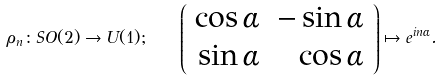<formula> <loc_0><loc_0><loc_500><loc_500>\rho _ { n } \colon S O ( 2 ) \to U ( 1 ) ; \quad \left ( \begin{array} { r r } \cos \alpha & - \sin \alpha \\ \sin \alpha & \cos \alpha \end{array} \right ) \mapsto e ^ { i n \alpha } .</formula> 